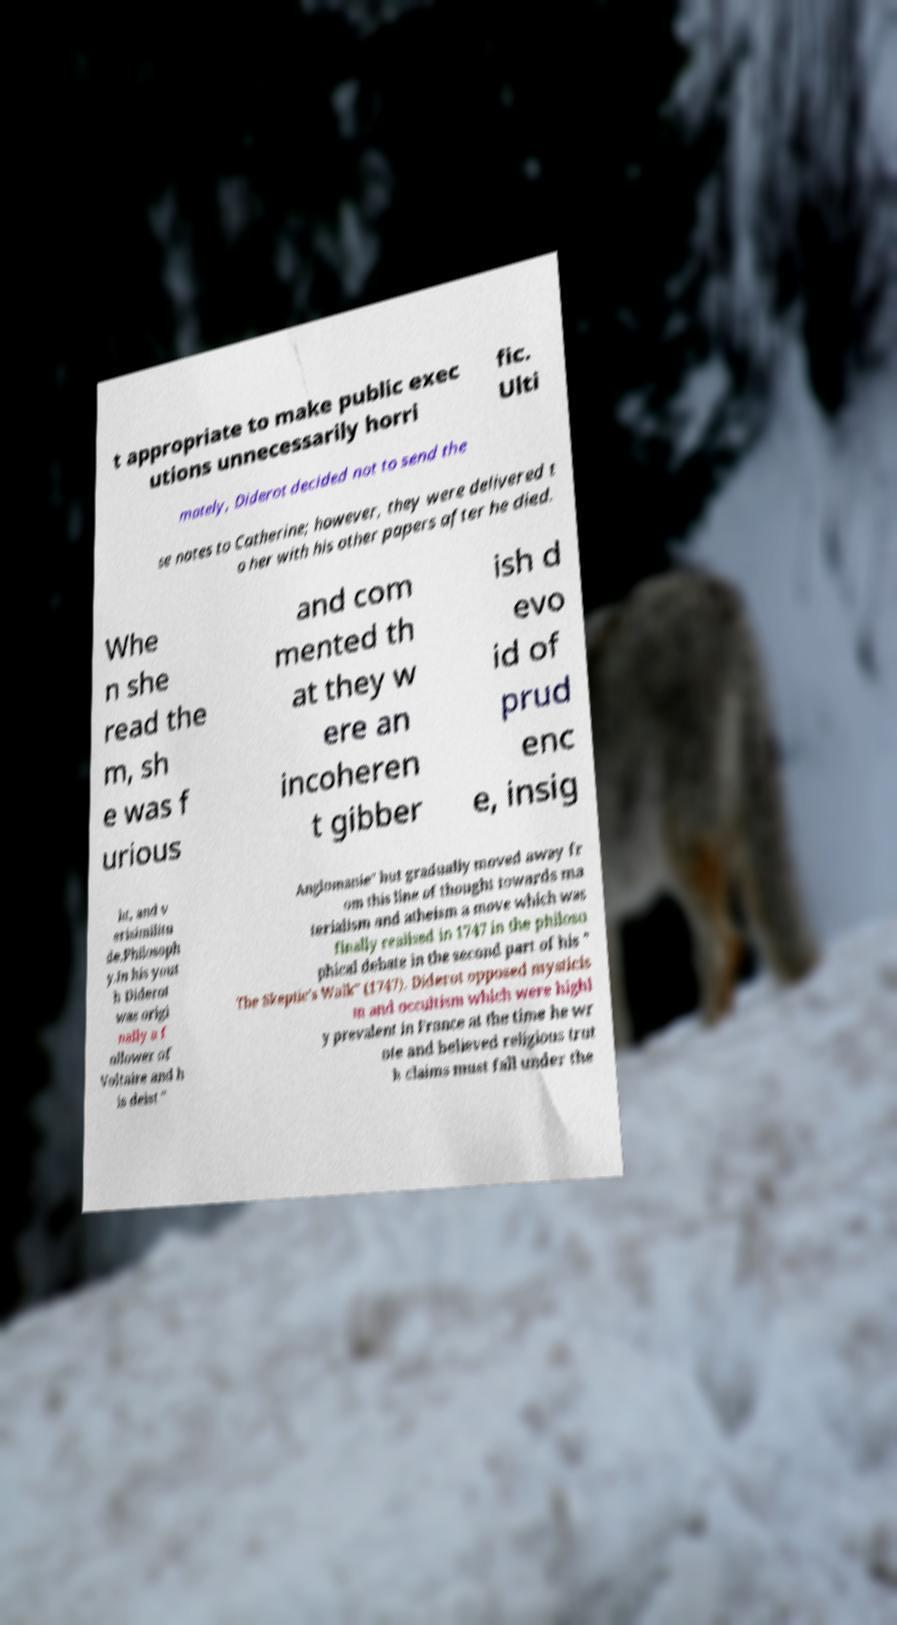There's text embedded in this image that I need extracted. Can you transcribe it verbatim? t appropriate to make public exec utions unnecessarily horri fic. Ulti mately, Diderot decided not to send the se notes to Catherine; however, they were delivered t o her with his other papers after he died. Whe n she read the m, sh e was f urious and com mented th at they w ere an incoheren t gibber ish d evo id of prud enc e, insig ht, and v erisimilitu de.Philosoph y.In his yout h Diderot was origi nally a f ollower of Voltaire and h is deist " Anglomanie" but gradually moved away fr om this line of thought towards ma terialism and atheism a move which was finally realised in 1747 in the philoso phical debate in the second part of his " The Skeptic's Walk" (1747). Diderot opposed mysticis m and occultism which were highl y prevalent in France at the time he wr ote and believed religious trut h claims must fall under the 